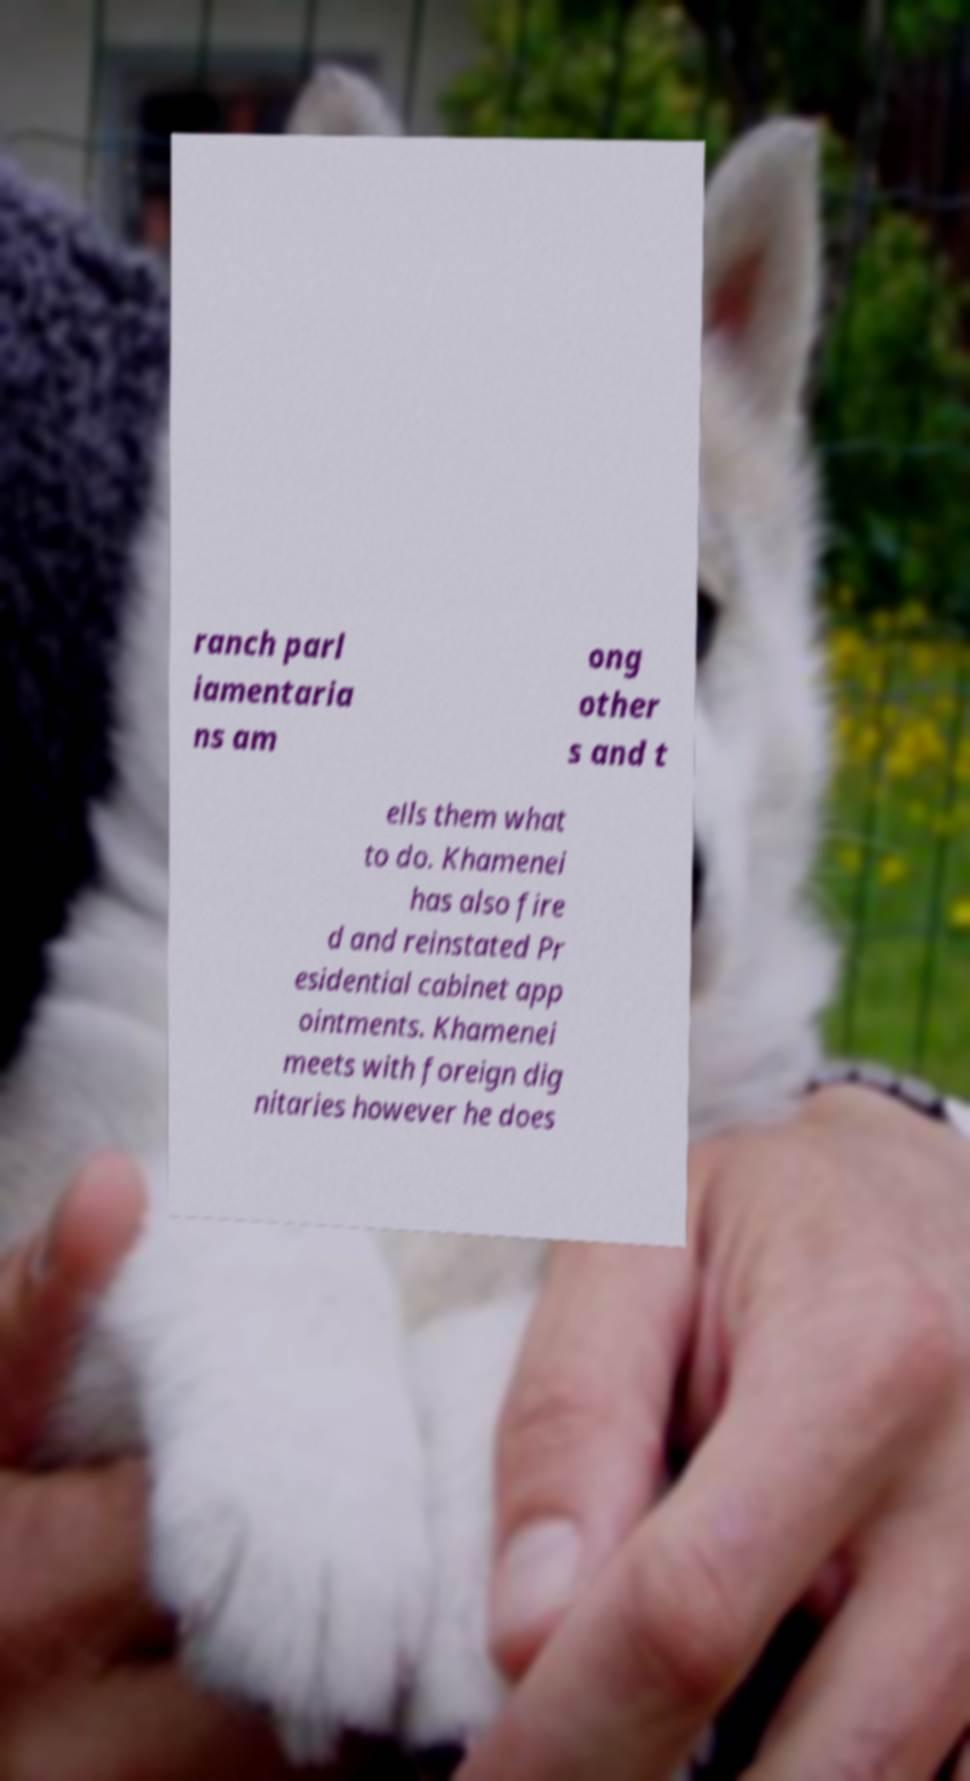There's text embedded in this image that I need extracted. Can you transcribe it verbatim? ranch parl iamentaria ns am ong other s and t ells them what to do. Khamenei has also fire d and reinstated Pr esidential cabinet app ointments. Khamenei meets with foreign dig nitaries however he does 